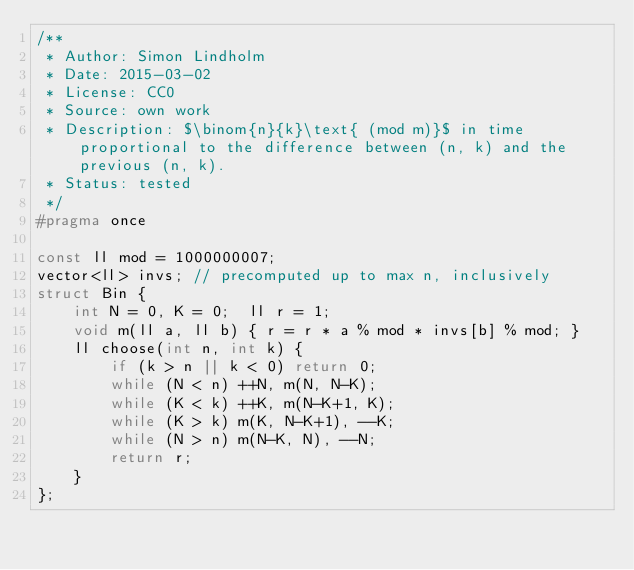Convert code to text. <code><loc_0><loc_0><loc_500><loc_500><_C_>/**
 * Author: Simon Lindholm
 * Date: 2015-03-02
 * License: CC0
 * Source: own work
 * Description: $\binom{n}{k}\text{ (mod m)}$ in time proportional to the difference between (n, k) and the previous (n, k).
 * Status: tested
 */
#pragma once

const ll mod = 1000000007;
vector<ll> invs; // precomputed up to max n, inclusively
struct Bin {
	int N = 0, K = 0;  ll r = 1;
	void m(ll a, ll b) { r = r * a % mod * invs[b] % mod; }
	ll choose(int n, int k) {
		if (k > n || k < 0) return 0;
		while (N < n) ++N, m(N, N-K);
		while (K < k) ++K, m(N-K+1, K);
		while (K > k) m(K, N-K+1), --K;
		while (N > n) m(N-K, N), --N;
		return r;
	}
};
</code> 